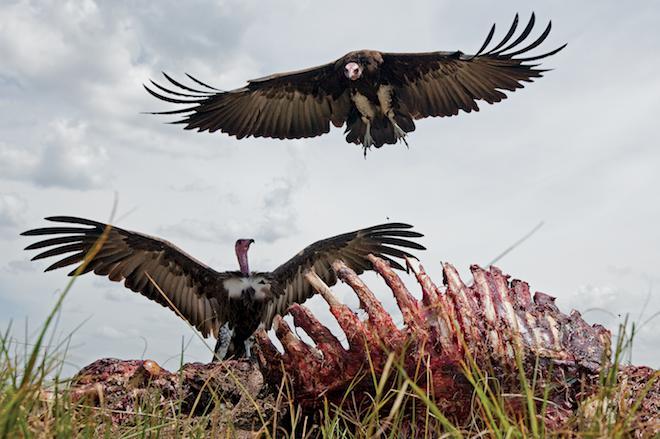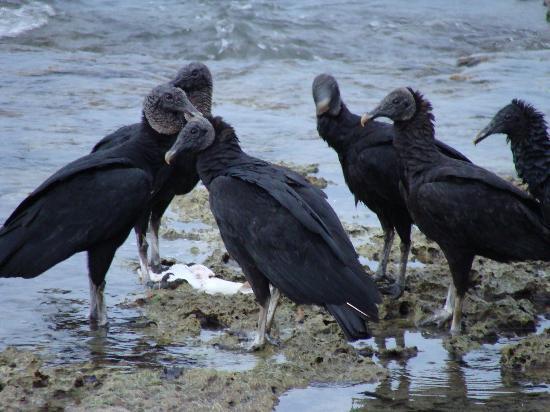The first image is the image on the left, the second image is the image on the right. Analyze the images presented: Is the assertion "There is a bird in flight not touching the ground." valid? Answer yes or no. Yes. The first image is the image on the left, the second image is the image on the right. Given the left and right images, does the statement "There are three birds, two of which are facing left, and one of which is facing right." hold true? Answer yes or no. No. 